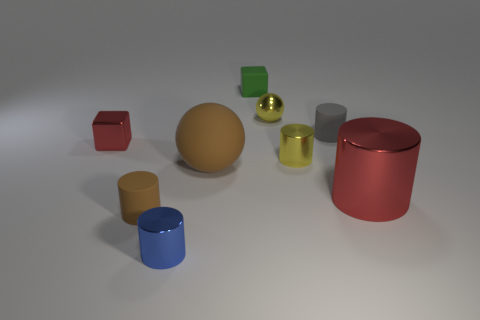Is the number of blue metallic objects that are behind the blue metal object less than the number of large brown rubber cubes?
Ensure brevity in your answer.  No. There is a object that is the same color as the small shiny cube; what is its size?
Give a very brief answer. Large. Are there any other things that are the same size as the gray rubber object?
Offer a very short reply. Yes. Does the small yellow cylinder have the same material as the tiny green thing?
Provide a succinct answer. No. How many things are either tiny cylinders in front of the large red cylinder or tiny metal objects that are to the right of the brown cylinder?
Give a very brief answer. 4. Is there a blue metallic object of the same size as the brown matte cylinder?
Offer a terse response. Yes. What color is the small shiny thing that is the same shape as the big rubber thing?
Offer a very short reply. Yellow. There is a brown matte object that is behind the tiny brown cylinder; is there a gray rubber thing that is left of it?
Provide a short and direct response. No. There is a tiny yellow object that is behind the tiny yellow cylinder; does it have the same shape as the tiny gray object?
Keep it short and to the point. No. What is the shape of the small green matte object?
Provide a succinct answer. Cube. 